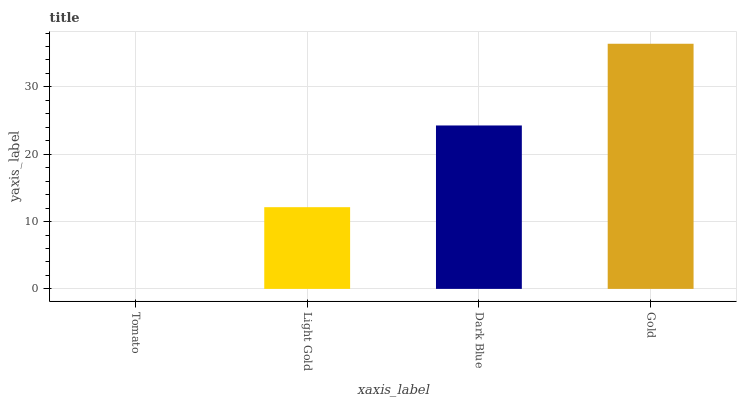Is Tomato the minimum?
Answer yes or no. Yes. Is Gold the maximum?
Answer yes or no. Yes. Is Light Gold the minimum?
Answer yes or no. No. Is Light Gold the maximum?
Answer yes or no. No. Is Light Gold greater than Tomato?
Answer yes or no. Yes. Is Tomato less than Light Gold?
Answer yes or no. Yes. Is Tomato greater than Light Gold?
Answer yes or no. No. Is Light Gold less than Tomato?
Answer yes or no. No. Is Dark Blue the high median?
Answer yes or no. Yes. Is Light Gold the low median?
Answer yes or no. Yes. Is Tomato the high median?
Answer yes or no. No. Is Tomato the low median?
Answer yes or no. No. 